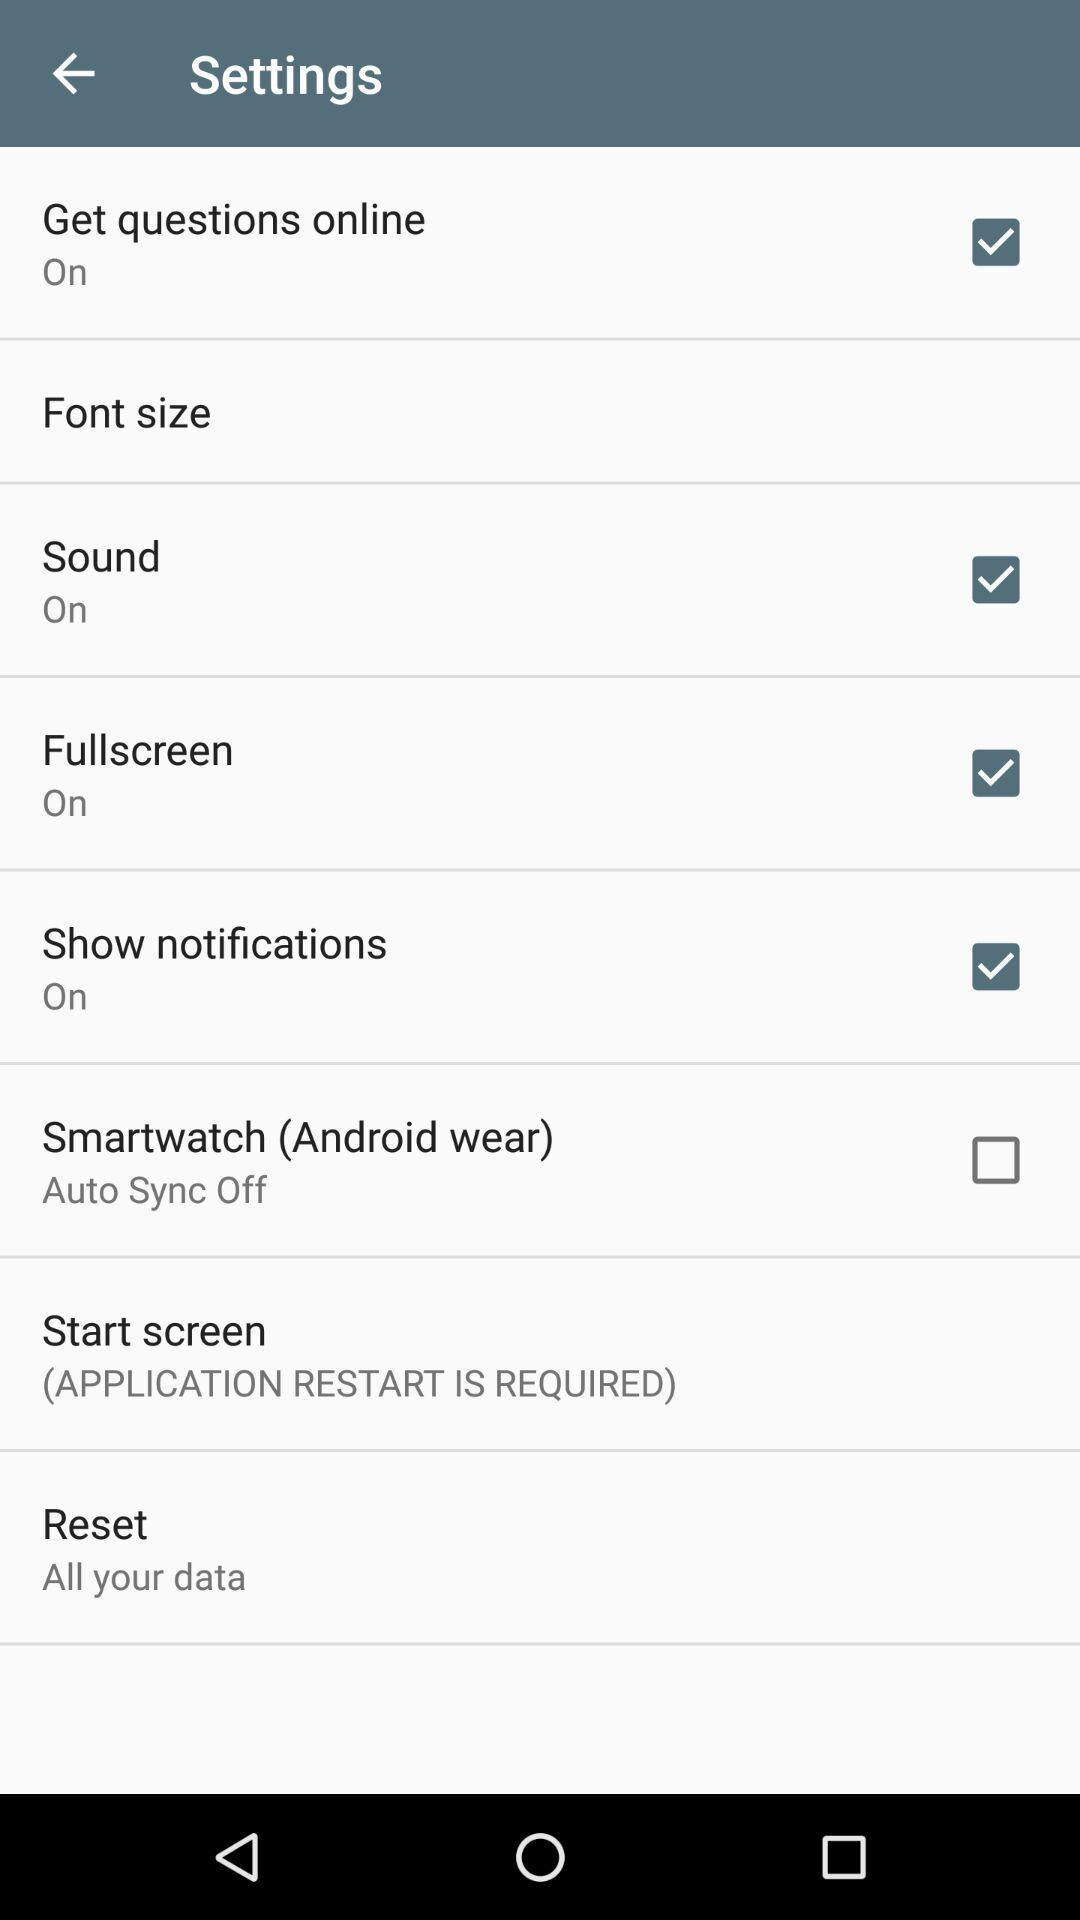What is the status of "Fullscreen"? The status is "on". 